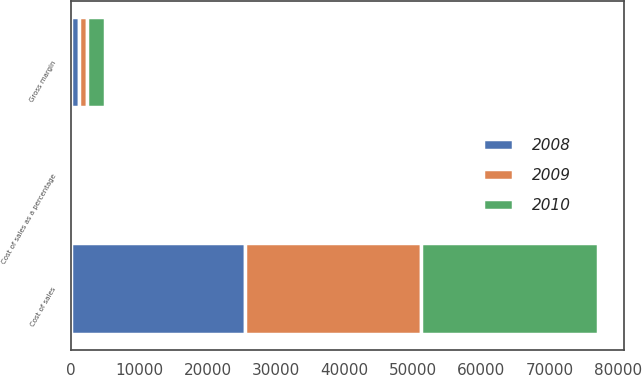Convert chart to OTSL. <chart><loc_0><loc_0><loc_500><loc_500><stacked_bar_chart><ecel><fcel>Cost of sales<fcel>Gross margin<fcel>Cost of sales as a percentage<nl><fcel>2010<fcel>25916<fcel>2514<fcel>91.2<nl><fcel>2008<fcel>25501<fcel>1203<fcel>95.5<nl><fcel>2009<fcel>25616<fcel>1246<fcel>95.4<nl></chart> 